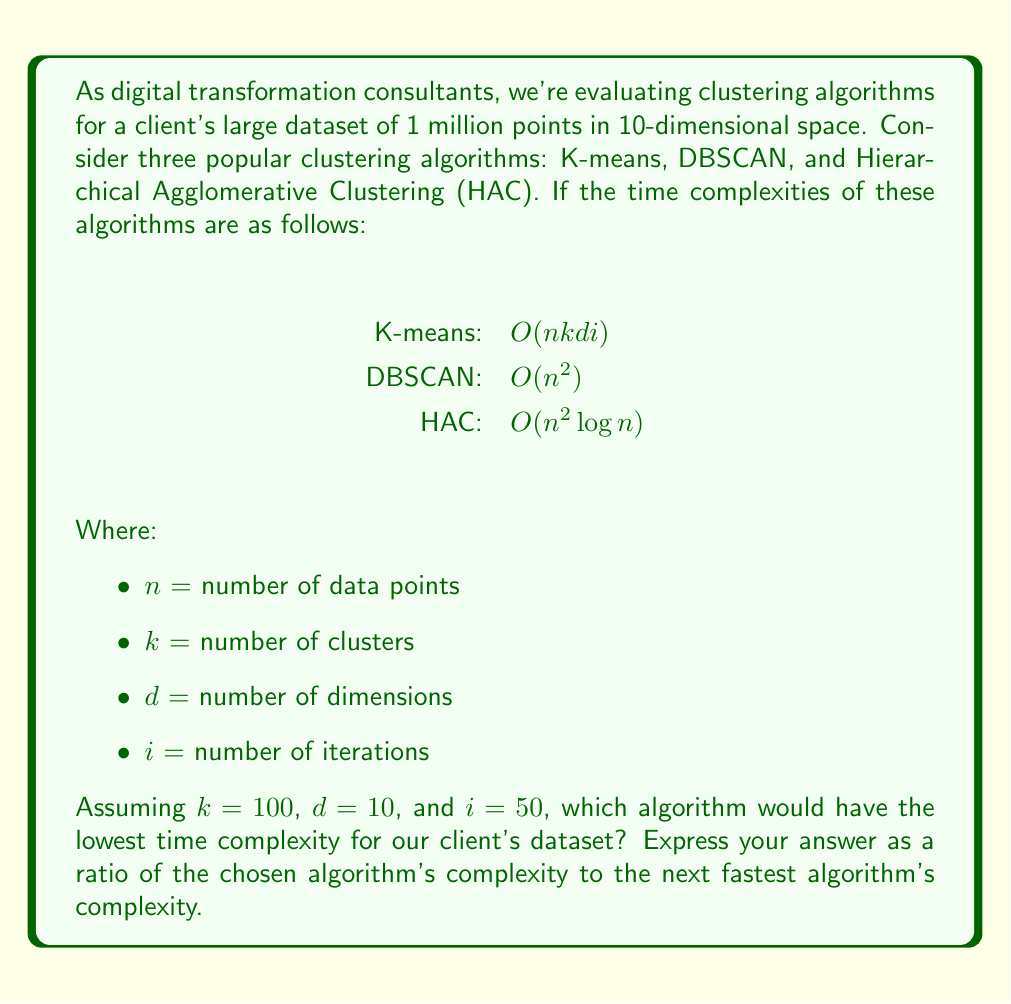Show me your answer to this math problem. To solve this problem, we need to calculate the time complexity for each algorithm using the given parameters and compare them:

1. K-means:
   $O(nkdi) = O(1,000,000 \times 100 \times 10 \times 50) = O(5 \times 10^{10})$

2. DBSCAN:
   $O(n^2) = O((1,000,000)^2) = O(10^{12})$

3. HAC:
   $O(n^2 \log n) = O((1,000,000)^2 \times \log(1,000,000))$ 
   $= O(10^{12} \times \log(10^6)) = O(10^{12} \times 6 \log(10)) \approx O(1.38 \times 10^{13})$

Comparing these complexities:

K-means: $5 \times 10^{10}$
DBSCAN: $10^{12}$
HAC: $1.38 \times 10^{13}$

We can see that K-means has the lowest time complexity for this dataset.

To express the answer as a ratio of the chosen algorithm's complexity to the next fastest algorithm's complexity, we need to compare K-means to DBSCAN:

Ratio = $\frac{\text{K-means complexity}}{\text{DBSCAN complexity}} = \frac{5 \times 10^{10}}{10^{12}} = \frac{5}{100} = 0.05$

This means K-means is approximately 20 times faster than the next fastest algorithm (DBSCAN) for this specific dataset and parameter configuration.
Answer: 0.05 